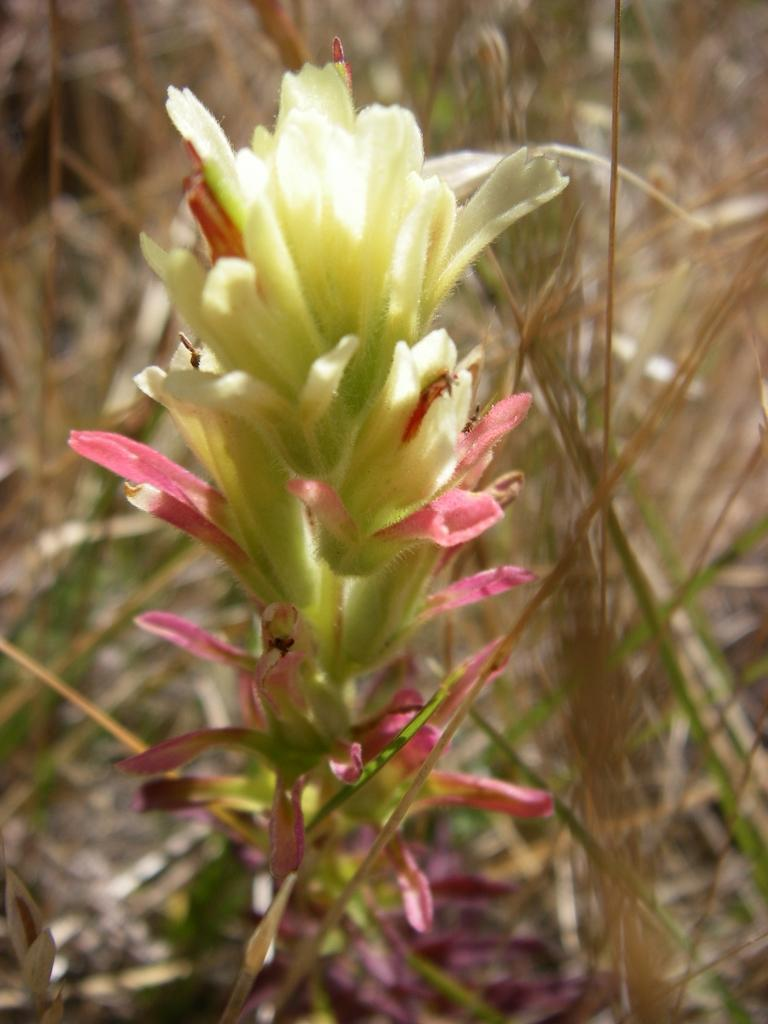What is the main subject in the foreground of the image? There is a flower in the foreground of the image. What type of vegetation can be seen in the background of the image? There is grass in the background of the image. How is the background of the image depicted? The background is mostly blurred. What type of toothbrush is being used to water the flower in the image? There is no toothbrush present in the image, and the flower is not being watered. 